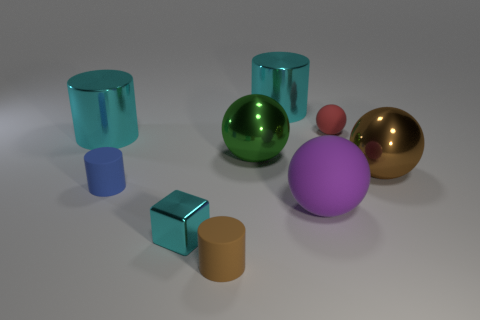Add 1 large green metallic balls. How many objects exist? 10 Subtract all blocks. How many objects are left? 8 Add 4 metal spheres. How many metal spheres are left? 6 Add 6 big rubber spheres. How many big rubber spheres exist? 7 Subtract 0 yellow cylinders. How many objects are left? 9 Subtract all blue objects. Subtract all big cyan cylinders. How many objects are left? 6 